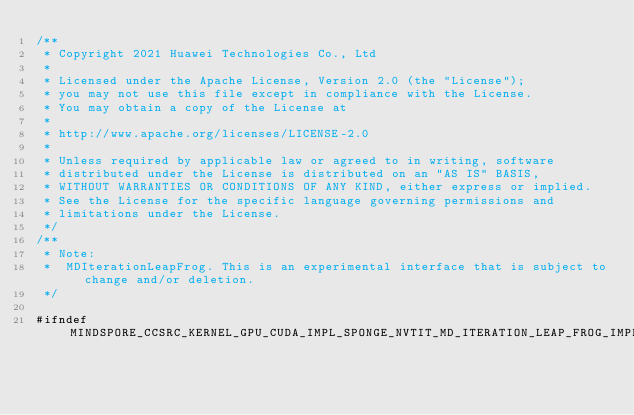<code> <loc_0><loc_0><loc_500><loc_500><_Cuda_>/**
 * Copyright 2021 Huawei Technologies Co., Ltd
 *
 * Licensed under the Apache License, Version 2.0 (the "License");
 * you may not use this file except in compliance with the License.
 * You may obtain a copy of the License at
 *
 * http://www.apache.org/licenses/LICENSE-2.0
 *
 * Unless required by applicable law or agreed to in writing, software
 * distributed under the License is distributed on an "AS IS" BASIS,
 * WITHOUT WARRANTIES OR CONDITIONS OF ANY KIND, either express or implied.
 * See the License for the specific language governing permissions and
 * limitations under the License.
 */
/**
 * Note:
 *  MDIterationLeapFrog. This is an experimental interface that is subject to change and/or deletion.
 */

#ifndef MINDSPORE_CCSRC_KERNEL_GPU_CUDA_IMPL_SPONGE_NVTIT_MD_ITERATION_LEAP_FROG_IMPL_H</code> 